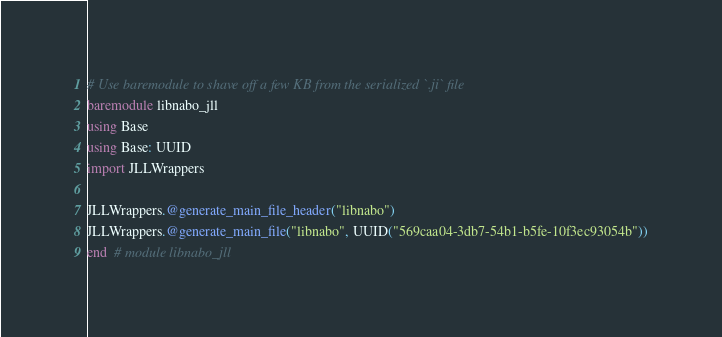Convert code to text. <code><loc_0><loc_0><loc_500><loc_500><_Julia_># Use baremodule to shave off a few KB from the serialized `.ji` file
baremodule libnabo_jll
using Base
using Base: UUID
import JLLWrappers

JLLWrappers.@generate_main_file_header("libnabo")
JLLWrappers.@generate_main_file("libnabo", UUID("569caa04-3db7-54b1-b5fe-10f3ec93054b"))
end  # module libnabo_jll
</code> 